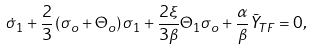<formula> <loc_0><loc_0><loc_500><loc_500>\dot { \sigma } _ { 1 } + \frac { 2 } { 3 } \left ( \sigma _ { o } + \Theta _ { o } \right ) \sigma _ { 1 } + \frac { 2 \xi } { 3 \beta } \Theta _ { 1 } \sigma _ { o } + \frac { \alpha } { \beta } \bar { Y } _ { T F } = 0 ,</formula> 